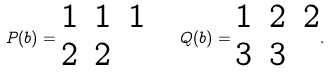<formula> <loc_0><loc_0><loc_500><loc_500>P ( b ) = \begin{matrix} 1 & 1 & 1 \\ 2 & 2 & \end{matrix} \quad Q ( b ) = \begin{matrix} 1 & 2 & 2 \\ 3 & 3 & \end{matrix} .</formula> 